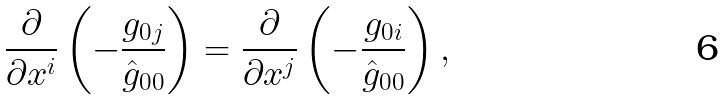Convert formula to latex. <formula><loc_0><loc_0><loc_500><loc_500>\frac { \partial } { \partial x ^ { i } } \left ( - \frac { g _ { 0 j } } { \hat { g } _ { 0 0 } } \right ) = \frac { \partial } { \partial x ^ { j } } \left ( - \frac { g _ { 0 i } } { \hat { g } _ { 0 0 } } \right ) ,</formula> 